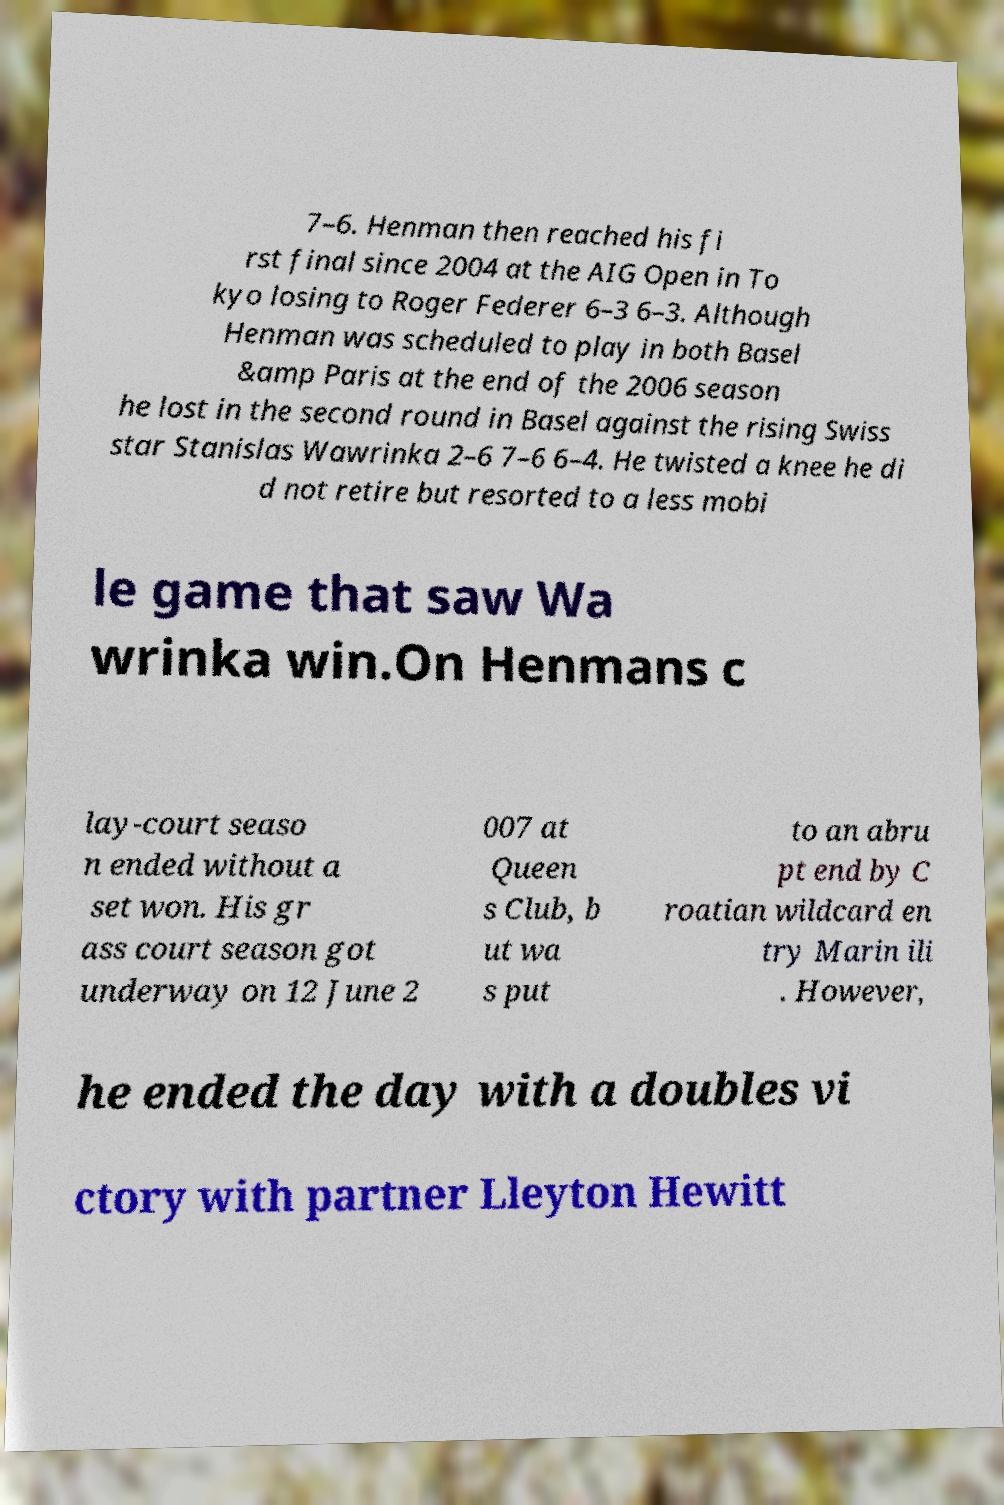I need the written content from this picture converted into text. Can you do that? 7–6. Henman then reached his fi rst final since 2004 at the AIG Open in To kyo losing to Roger Federer 6–3 6–3. Although Henman was scheduled to play in both Basel &amp Paris at the end of the 2006 season he lost in the second round in Basel against the rising Swiss star Stanislas Wawrinka 2–6 7–6 6–4. He twisted a knee he di d not retire but resorted to a less mobi le game that saw Wa wrinka win.On Henmans c lay-court seaso n ended without a set won. His gr ass court season got underway on 12 June 2 007 at Queen s Club, b ut wa s put to an abru pt end by C roatian wildcard en try Marin ili . However, he ended the day with a doubles vi ctory with partner Lleyton Hewitt 